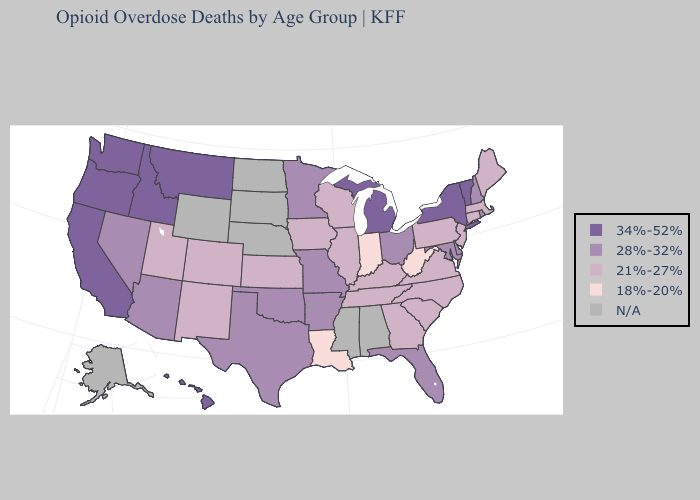Does Delaware have the highest value in the USA?
Answer briefly. No. Does Massachusetts have the lowest value in the Northeast?
Quick response, please. Yes. Among the states that border Nevada , does California have the lowest value?
Give a very brief answer. No. What is the lowest value in the USA?
Keep it brief. 18%-20%. Name the states that have a value in the range N/A?
Short answer required. Alabama, Alaska, Mississippi, Nebraska, North Dakota, South Dakota, Wyoming. Which states have the highest value in the USA?
Answer briefly. California, Hawaii, Idaho, Michigan, Montana, New York, Oregon, Vermont, Washington. What is the highest value in the USA?
Concise answer only. 34%-52%. How many symbols are there in the legend?
Give a very brief answer. 5. What is the value of Montana?
Quick response, please. 34%-52%. What is the lowest value in states that border Minnesota?
Concise answer only. 21%-27%. What is the lowest value in the MidWest?
Quick response, please. 18%-20%. Name the states that have a value in the range 34%-52%?
Short answer required. California, Hawaii, Idaho, Michigan, Montana, New York, Oregon, Vermont, Washington. Which states have the highest value in the USA?
Answer briefly. California, Hawaii, Idaho, Michigan, Montana, New York, Oregon, Vermont, Washington. Name the states that have a value in the range 28%-32%?
Keep it brief. Arizona, Arkansas, Delaware, Florida, Maryland, Minnesota, Missouri, Nevada, New Hampshire, Ohio, Oklahoma, Rhode Island, Texas. 